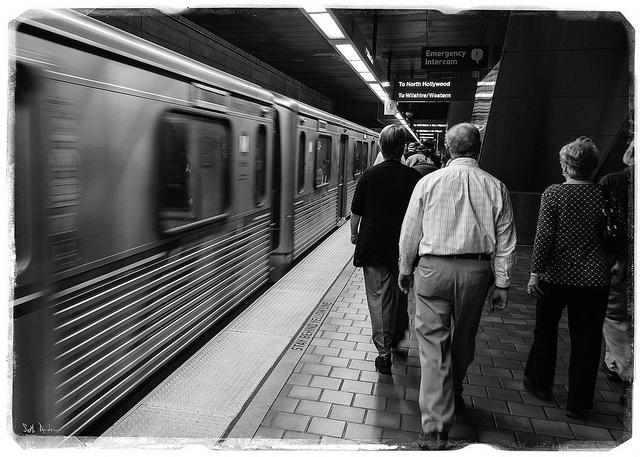What must be paid to ride this machine? fare 